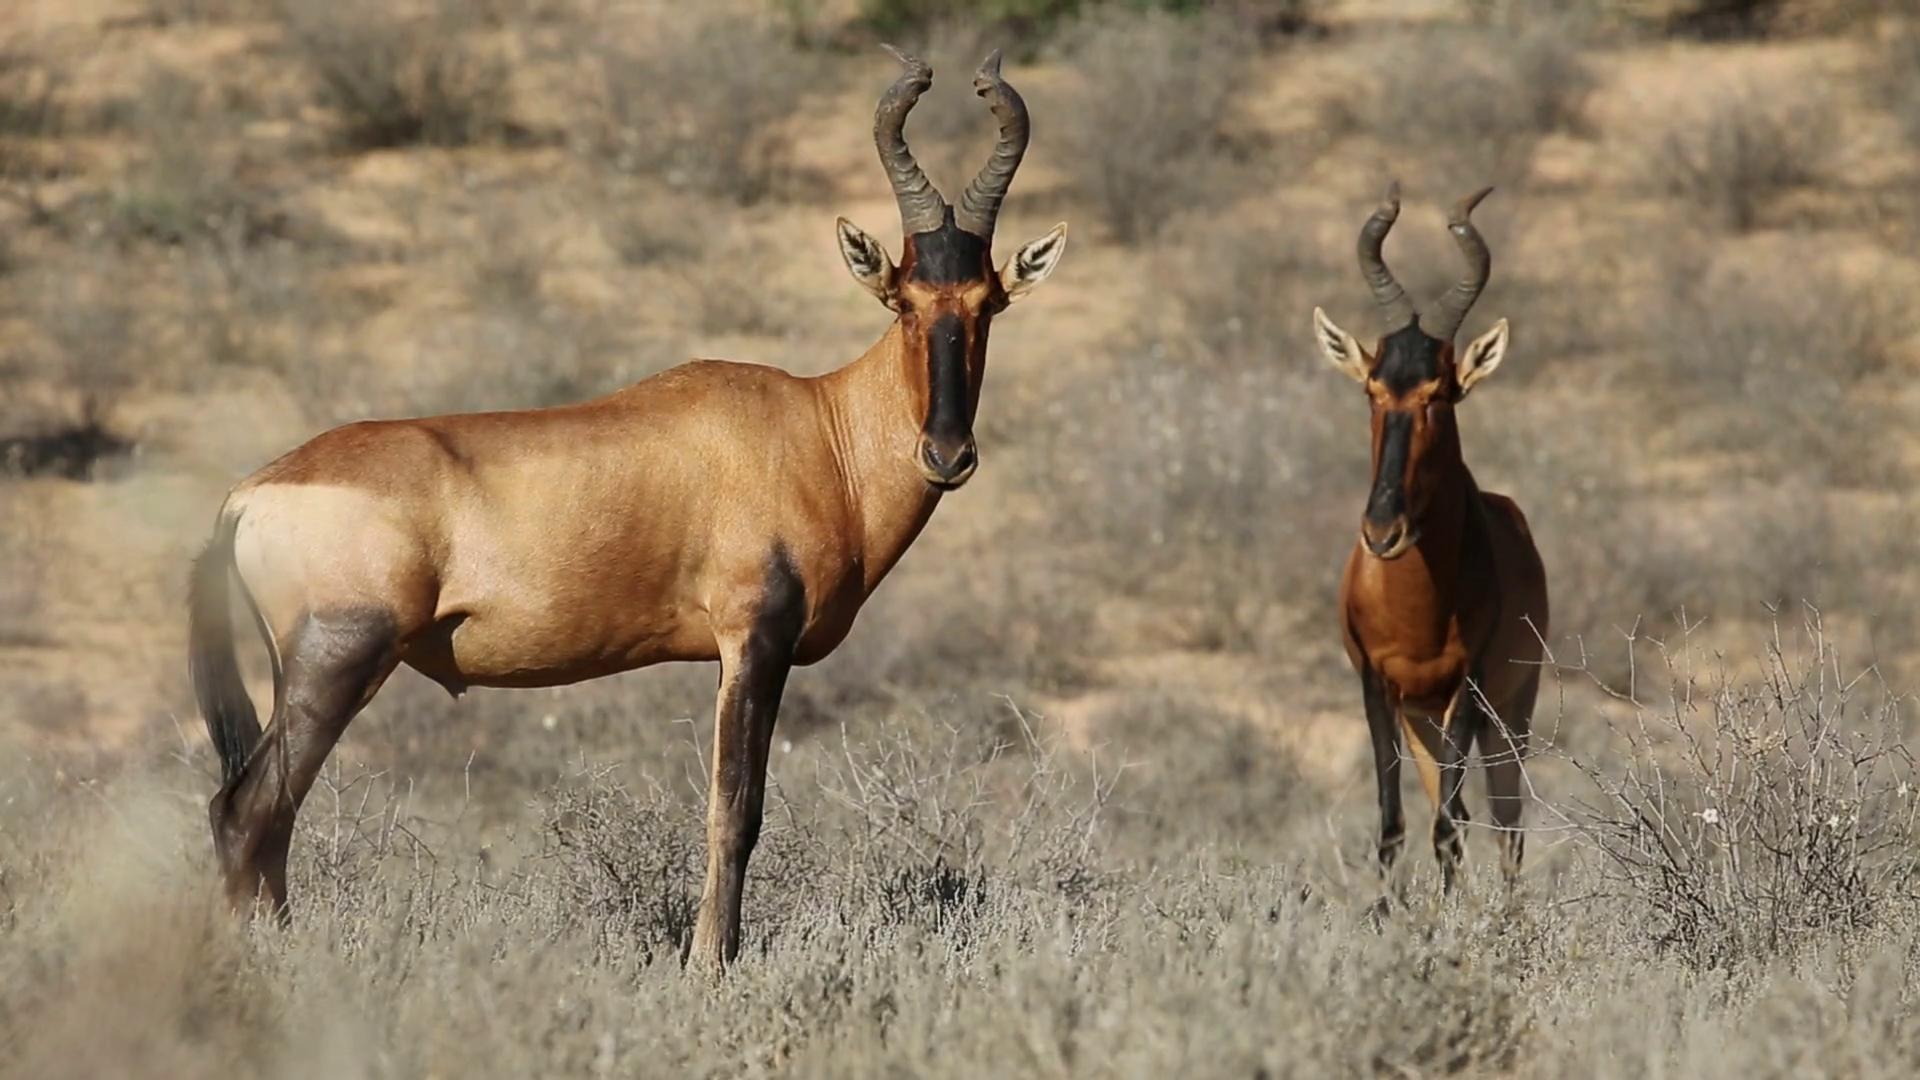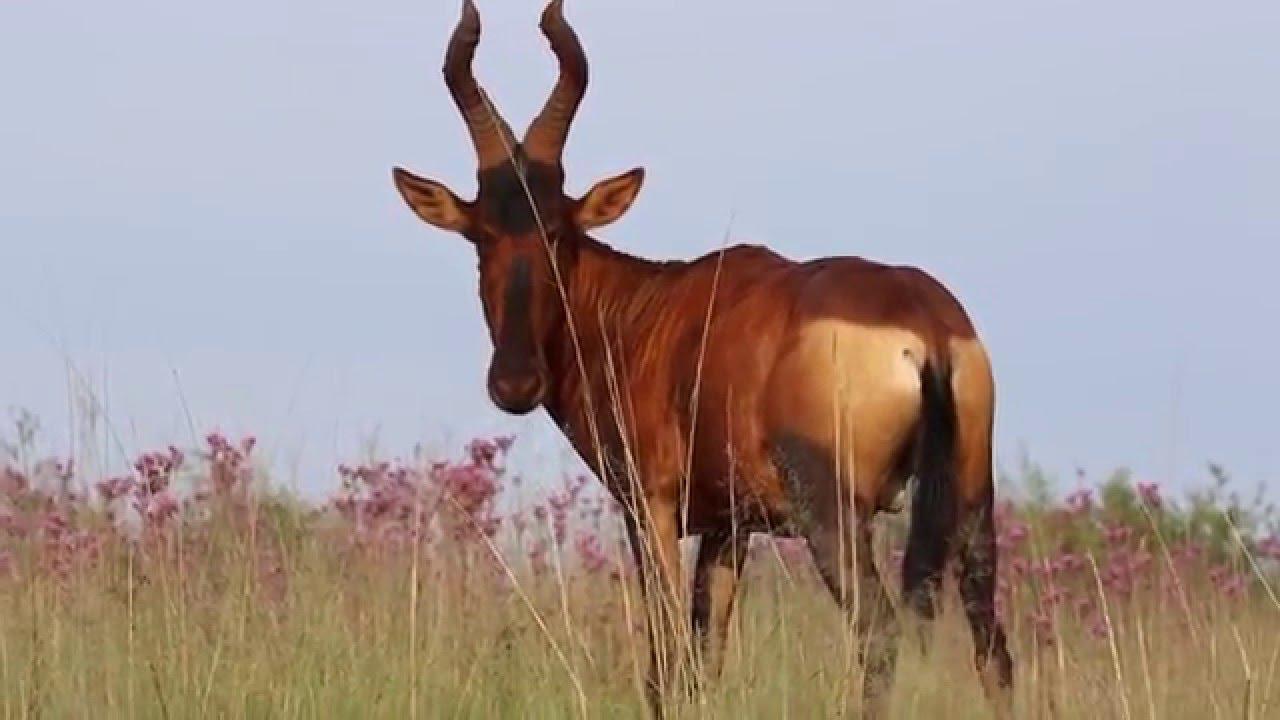The first image is the image on the left, the second image is the image on the right. Given the left and right images, does the statement "There are exactly two animals standing." hold true? Answer yes or no. No. The first image is the image on the left, the second image is the image on the right. For the images shown, is this caption "Only two antelopes are visible in the left image." true? Answer yes or no. Yes. 